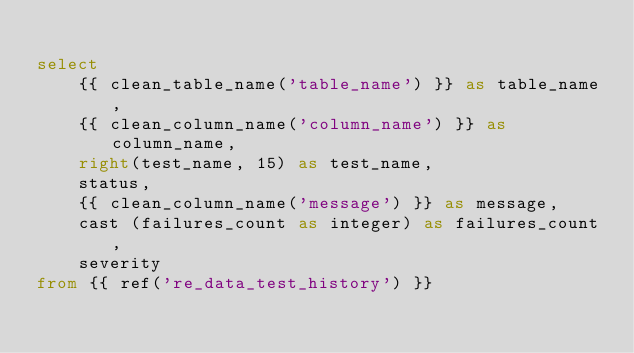<code> <loc_0><loc_0><loc_500><loc_500><_SQL_>
select
    {{ clean_table_name('table_name') }} as table_name,
    {{ clean_column_name('column_name') }} as column_name,
    right(test_name, 15) as test_name,
    status,
    {{ clean_column_name('message') }} as message,
    cast (failures_count as integer) as failures_count,
    severity
from {{ ref('re_data_test_history') }}</code> 